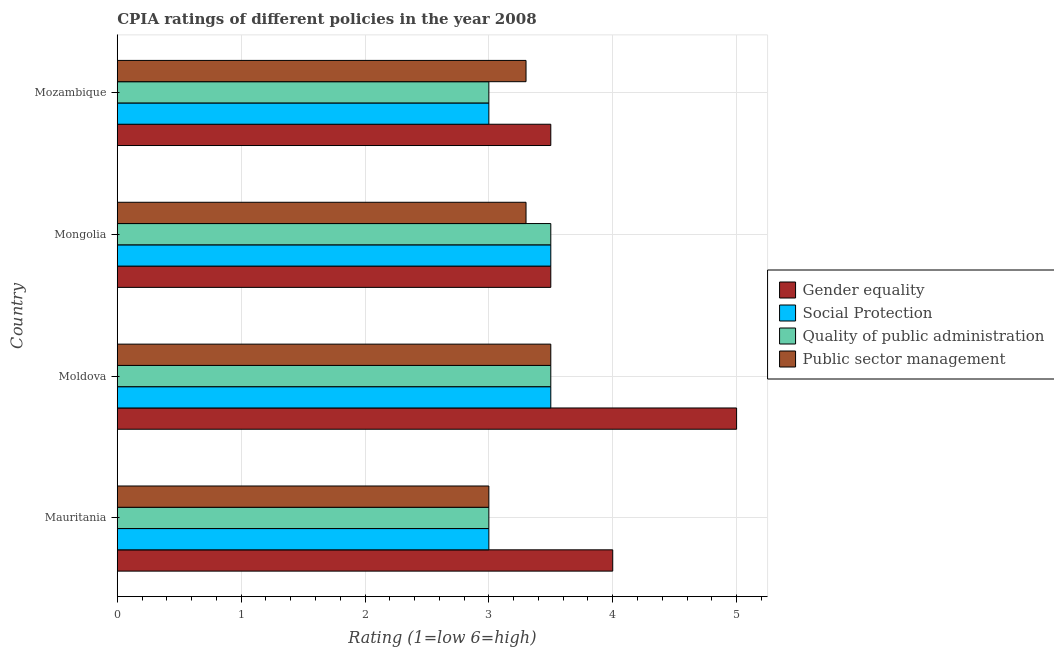How many groups of bars are there?
Your response must be concise. 4. Are the number of bars per tick equal to the number of legend labels?
Provide a succinct answer. Yes. Are the number of bars on each tick of the Y-axis equal?
Offer a terse response. Yes. How many bars are there on the 4th tick from the top?
Offer a very short reply. 4. How many bars are there on the 1st tick from the bottom?
Your response must be concise. 4. What is the label of the 3rd group of bars from the top?
Your answer should be compact. Moldova. In how many cases, is the number of bars for a given country not equal to the number of legend labels?
Give a very brief answer. 0. What is the cpia rating of quality of public administration in Mauritania?
Make the answer very short. 3. Across all countries, what is the maximum cpia rating of gender equality?
Your answer should be very brief. 5. Across all countries, what is the minimum cpia rating of social protection?
Your answer should be compact. 3. In which country was the cpia rating of social protection maximum?
Give a very brief answer. Moldova. In which country was the cpia rating of social protection minimum?
Ensure brevity in your answer.  Mauritania. What is the total cpia rating of social protection in the graph?
Keep it short and to the point. 13. What is the difference between the cpia rating of gender equality in Moldova and the cpia rating of quality of public administration in Mauritania?
Offer a very short reply. 2. What is the average cpia rating of social protection per country?
Your answer should be very brief. 3.25. What is the ratio of the cpia rating of public sector management in Mauritania to that in Mongolia?
Your response must be concise. 0.91. What is the difference between the highest and the second highest cpia rating of gender equality?
Your response must be concise. 1. In how many countries, is the cpia rating of social protection greater than the average cpia rating of social protection taken over all countries?
Your answer should be compact. 2. Is the sum of the cpia rating of quality of public administration in Moldova and Mongolia greater than the maximum cpia rating of public sector management across all countries?
Keep it short and to the point. Yes. What does the 3rd bar from the top in Mongolia represents?
Offer a very short reply. Social Protection. What does the 2nd bar from the bottom in Mozambique represents?
Give a very brief answer. Social Protection. Is it the case that in every country, the sum of the cpia rating of gender equality and cpia rating of social protection is greater than the cpia rating of quality of public administration?
Give a very brief answer. Yes. How many bars are there?
Offer a terse response. 16. Are all the bars in the graph horizontal?
Provide a succinct answer. Yes. Where does the legend appear in the graph?
Provide a succinct answer. Center right. What is the title of the graph?
Offer a very short reply. CPIA ratings of different policies in the year 2008. What is the label or title of the Y-axis?
Offer a very short reply. Country. What is the Rating (1=low 6=high) of Social Protection in Mauritania?
Offer a very short reply. 3. What is the Rating (1=low 6=high) in Gender equality in Moldova?
Offer a terse response. 5. What is the Rating (1=low 6=high) of Quality of public administration in Moldova?
Provide a succinct answer. 3.5. What is the Rating (1=low 6=high) in Public sector management in Moldova?
Make the answer very short. 3.5. What is the Rating (1=low 6=high) of Social Protection in Mongolia?
Your answer should be very brief. 3.5. What is the Rating (1=low 6=high) in Quality of public administration in Mongolia?
Provide a succinct answer. 3.5. What is the Rating (1=low 6=high) of Public sector management in Mongolia?
Provide a succinct answer. 3.3. What is the Rating (1=low 6=high) of Social Protection in Mozambique?
Provide a short and direct response. 3. What is the Rating (1=low 6=high) of Quality of public administration in Mozambique?
Ensure brevity in your answer.  3. What is the Rating (1=low 6=high) in Public sector management in Mozambique?
Provide a succinct answer. 3.3. Across all countries, what is the maximum Rating (1=low 6=high) of Gender equality?
Your answer should be very brief. 5. Across all countries, what is the maximum Rating (1=low 6=high) in Social Protection?
Your answer should be very brief. 3.5. Across all countries, what is the maximum Rating (1=low 6=high) in Quality of public administration?
Offer a very short reply. 3.5. Across all countries, what is the maximum Rating (1=low 6=high) in Public sector management?
Give a very brief answer. 3.5. Across all countries, what is the minimum Rating (1=low 6=high) in Quality of public administration?
Your answer should be compact. 3. Across all countries, what is the minimum Rating (1=low 6=high) of Public sector management?
Provide a short and direct response. 3. What is the total Rating (1=low 6=high) in Social Protection in the graph?
Keep it short and to the point. 13. What is the difference between the Rating (1=low 6=high) of Gender equality in Mauritania and that in Moldova?
Provide a succinct answer. -1. What is the difference between the Rating (1=low 6=high) of Social Protection in Mauritania and that in Moldova?
Provide a short and direct response. -0.5. What is the difference between the Rating (1=low 6=high) of Quality of public administration in Mauritania and that in Moldova?
Ensure brevity in your answer.  -0.5. What is the difference between the Rating (1=low 6=high) in Public sector management in Mauritania and that in Moldova?
Give a very brief answer. -0.5. What is the difference between the Rating (1=low 6=high) in Social Protection in Moldova and that in Mongolia?
Your answer should be very brief. 0. What is the difference between the Rating (1=low 6=high) in Gender equality in Moldova and that in Mozambique?
Keep it short and to the point. 1.5. What is the difference between the Rating (1=low 6=high) of Quality of public administration in Moldova and that in Mozambique?
Offer a terse response. 0.5. What is the difference between the Rating (1=low 6=high) of Public sector management in Moldova and that in Mozambique?
Offer a terse response. 0.2. What is the difference between the Rating (1=low 6=high) of Quality of public administration in Mongolia and that in Mozambique?
Give a very brief answer. 0.5. What is the difference between the Rating (1=low 6=high) in Public sector management in Mongolia and that in Mozambique?
Your response must be concise. 0. What is the difference between the Rating (1=low 6=high) of Gender equality in Mauritania and the Rating (1=low 6=high) of Social Protection in Moldova?
Your answer should be compact. 0.5. What is the difference between the Rating (1=low 6=high) of Social Protection in Mauritania and the Rating (1=low 6=high) of Quality of public administration in Moldova?
Offer a terse response. -0.5. What is the difference between the Rating (1=low 6=high) of Gender equality in Mauritania and the Rating (1=low 6=high) of Social Protection in Mongolia?
Keep it short and to the point. 0.5. What is the difference between the Rating (1=low 6=high) in Gender equality in Mauritania and the Rating (1=low 6=high) in Public sector management in Mongolia?
Keep it short and to the point. 0.7. What is the difference between the Rating (1=low 6=high) of Gender equality in Mauritania and the Rating (1=low 6=high) of Social Protection in Mozambique?
Your answer should be compact. 1. What is the difference between the Rating (1=low 6=high) in Social Protection in Mauritania and the Rating (1=low 6=high) in Public sector management in Mozambique?
Make the answer very short. -0.3. What is the difference between the Rating (1=low 6=high) in Quality of public administration in Mauritania and the Rating (1=low 6=high) in Public sector management in Mozambique?
Your answer should be compact. -0.3. What is the difference between the Rating (1=low 6=high) in Gender equality in Moldova and the Rating (1=low 6=high) in Quality of public administration in Mongolia?
Make the answer very short. 1.5. What is the difference between the Rating (1=low 6=high) of Gender equality in Moldova and the Rating (1=low 6=high) of Public sector management in Mongolia?
Offer a terse response. 1.7. What is the difference between the Rating (1=low 6=high) in Social Protection in Moldova and the Rating (1=low 6=high) in Quality of public administration in Mongolia?
Your response must be concise. 0. What is the difference between the Rating (1=low 6=high) in Social Protection in Moldova and the Rating (1=low 6=high) in Public sector management in Mongolia?
Offer a very short reply. 0.2. What is the difference between the Rating (1=low 6=high) in Quality of public administration in Moldova and the Rating (1=low 6=high) in Public sector management in Mongolia?
Keep it short and to the point. 0.2. What is the difference between the Rating (1=low 6=high) in Gender equality in Moldova and the Rating (1=low 6=high) in Quality of public administration in Mozambique?
Provide a short and direct response. 2. What is the difference between the Rating (1=low 6=high) in Gender equality in Moldova and the Rating (1=low 6=high) in Public sector management in Mozambique?
Ensure brevity in your answer.  1.7. What is the difference between the Rating (1=low 6=high) of Social Protection in Moldova and the Rating (1=low 6=high) of Quality of public administration in Mozambique?
Ensure brevity in your answer.  0.5. What is the difference between the Rating (1=low 6=high) in Social Protection in Mongolia and the Rating (1=low 6=high) in Quality of public administration in Mozambique?
Keep it short and to the point. 0.5. What is the difference between the Rating (1=low 6=high) of Social Protection in Mongolia and the Rating (1=low 6=high) of Public sector management in Mozambique?
Your answer should be very brief. 0.2. What is the average Rating (1=low 6=high) in Social Protection per country?
Offer a very short reply. 3.25. What is the average Rating (1=low 6=high) of Public sector management per country?
Offer a terse response. 3.27. What is the difference between the Rating (1=low 6=high) of Gender equality and Rating (1=low 6=high) of Social Protection in Mauritania?
Provide a short and direct response. 1. What is the difference between the Rating (1=low 6=high) of Social Protection and Rating (1=low 6=high) of Quality of public administration in Mauritania?
Keep it short and to the point. 0. What is the difference between the Rating (1=low 6=high) of Gender equality and Rating (1=low 6=high) of Public sector management in Moldova?
Offer a terse response. 1.5. What is the difference between the Rating (1=low 6=high) in Social Protection and Rating (1=low 6=high) in Quality of public administration in Moldova?
Keep it short and to the point. 0. What is the difference between the Rating (1=low 6=high) of Quality of public administration and Rating (1=low 6=high) of Public sector management in Moldova?
Offer a terse response. 0. What is the difference between the Rating (1=low 6=high) of Gender equality and Rating (1=low 6=high) of Quality of public administration in Mongolia?
Your answer should be very brief. 0. What is the difference between the Rating (1=low 6=high) in Gender equality and Rating (1=low 6=high) in Public sector management in Mongolia?
Offer a terse response. 0.2. What is the difference between the Rating (1=low 6=high) of Social Protection and Rating (1=low 6=high) of Quality of public administration in Mongolia?
Keep it short and to the point. 0. What is the difference between the Rating (1=low 6=high) of Social Protection and Rating (1=low 6=high) of Public sector management in Mongolia?
Your answer should be very brief. 0.2. What is the difference between the Rating (1=low 6=high) in Gender equality and Rating (1=low 6=high) in Quality of public administration in Mozambique?
Your answer should be compact. 0.5. What is the difference between the Rating (1=low 6=high) in Quality of public administration and Rating (1=low 6=high) in Public sector management in Mozambique?
Ensure brevity in your answer.  -0.3. What is the ratio of the Rating (1=low 6=high) in Social Protection in Mauritania to that in Moldova?
Make the answer very short. 0.86. What is the ratio of the Rating (1=low 6=high) in Quality of public administration in Mauritania to that in Mongolia?
Your answer should be compact. 0.86. What is the ratio of the Rating (1=low 6=high) in Public sector management in Mauritania to that in Mongolia?
Keep it short and to the point. 0.91. What is the ratio of the Rating (1=low 6=high) in Quality of public administration in Mauritania to that in Mozambique?
Provide a succinct answer. 1. What is the ratio of the Rating (1=low 6=high) in Gender equality in Moldova to that in Mongolia?
Your answer should be compact. 1.43. What is the ratio of the Rating (1=low 6=high) in Public sector management in Moldova to that in Mongolia?
Ensure brevity in your answer.  1.06. What is the ratio of the Rating (1=low 6=high) in Gender equality in Moldova to that in Mozambique?
Your response must be concise. 1.43. What is the ratio of the Rating (1=low 6=high) of Quality of public administration in Moldova to that in Mozambique?
Ensure brevity in your answer.  1.17. What is the ratio of the Rating (1=low 6=high) of Public sector management in Moldova to that in Mozambique?
Your answer should be compact. 1.06. What is the ratio of the Rating (1=low 6=high) of Social Protection in Mongolia to that in Mozambique?
Offer a very short reply. 1.17. What is the ratio of the Rating (1=low 6=high) of Quality of public administration in Mongolia to that in Mozambique?
Provide a short and direct response. 1.17. What is the difference between the highest and the second highest Rating (1=low 6=high) in Social Protection?
Give a very brief answer. 0. What is the difference between the highest and the lowest Rating (1=low 6=high) of Gender equality?
Give a very brief answer. 1.5. What is the difference between the highest and the lowest Rating (1=low 6=high) in Quality of public administration?
Provide a short and direct response. 0.5. 